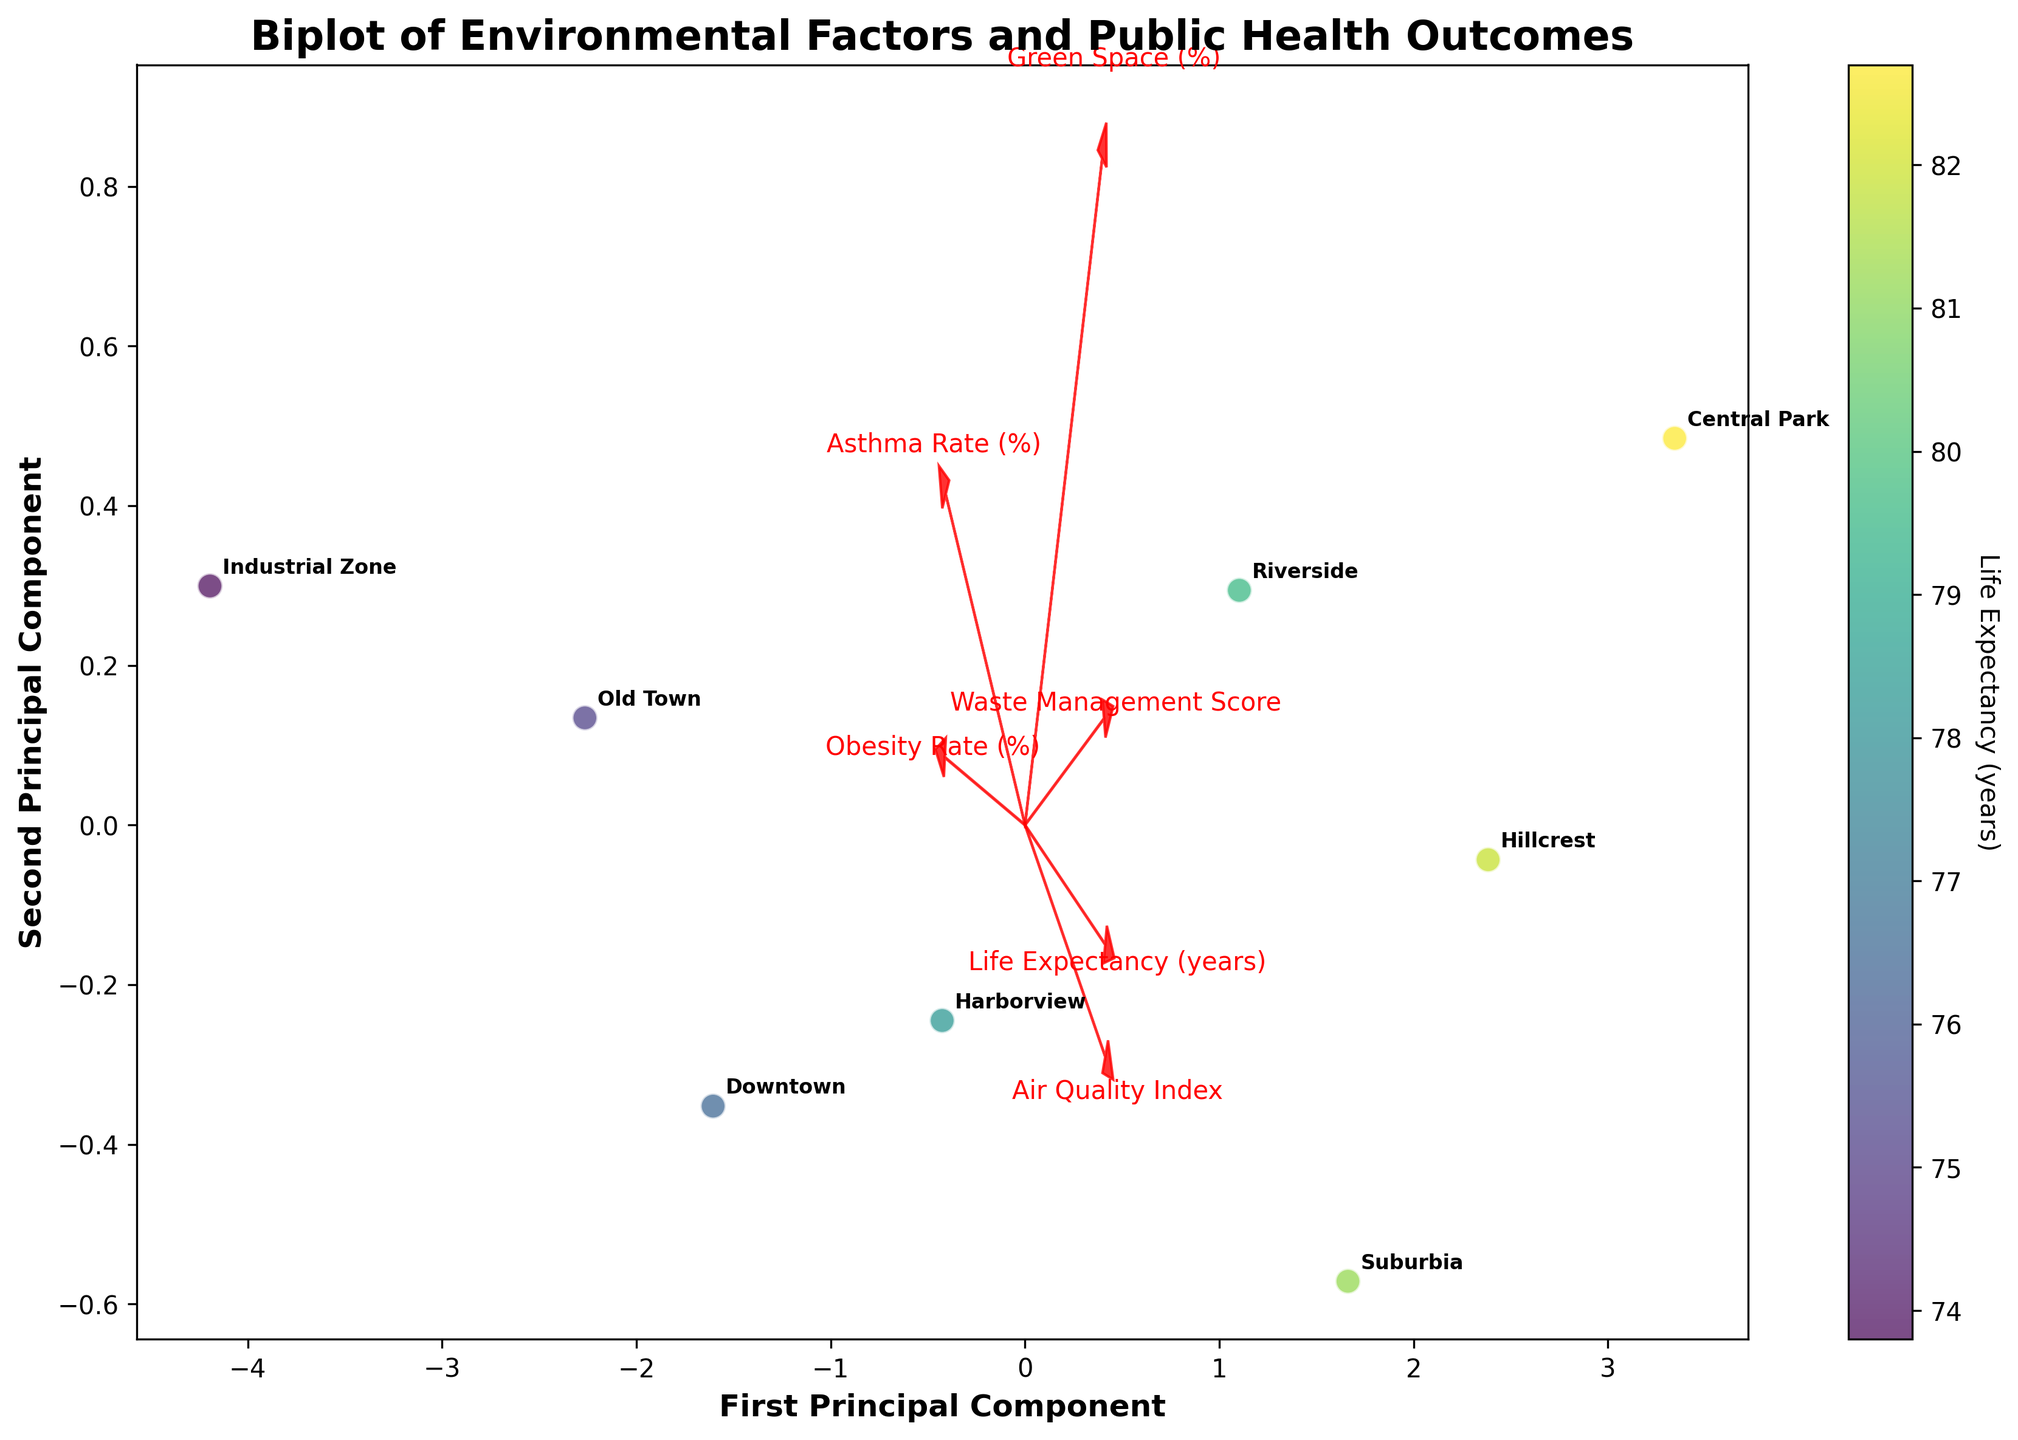What does the title of the biplot tell us? The title "Biplot of Environmental Factors and Public Health Outcomes" indicates that the plot displays data regarding various environmental factors in different neighborhoods and their corresponding public health outcomes.
Answer: Biplot of Environmental Factors and Public Health Outcomes What do the arrows in the biplot represent? The arrows represent the original environmental and public health variables. The direction and length of each arrow reflect the contribution of each variable to the first two principal components.
Answer: Original variables' contributions How many neighborhoods are represented in the biplot? There are 8 neighborhoods represented, as seen by 8 distinct data points labeled with neighborhood names.
Answer: 8 Which neighborhood has the highest Life Expectancy, and where is it located in the plot? Central Park has the highest Life Expectancy, as indicated by its label near the top-right corner of the biplot.
Answer: Central Park Which environmental factor is most strongly associated with increased Life Expectancy according to the biplot? The Green Space (%) variable tends to point in the same direction as the higher Life Expectancy values, implying a strong positive association.
Answer: Green Space (%) Which two neighborhoods have the most similar public health outcomes? Hillcrest and Suburbia appear close to each other in the biplot, suggesting they have similar public health outcomes.
Answer: Hillcrest and Suburbia How does Asthma Rate correlate with Waste Management Score in the biplot? Both Asthma Rate and Waste Management Score arrows point in nearly opposite directions, indicating an inverse correlation.
Answer: Inversely correlated What neighborhood has the highest Obesity Rate, and what can be inferred from its position? Industrial Zone has the highest Obesity Rate and is positioned far from variables linked positively with Life Expectancy, suggesting poorer health outcomes.
Answer: Industrial Zone Comparing Downtown and Harborview, which neighborhood has a better Air Quality Index? Harborview has a better Air Quality Index since its data point is closer to the Air Quality Index arrow direction in the biplot.
Answer: Harborview 